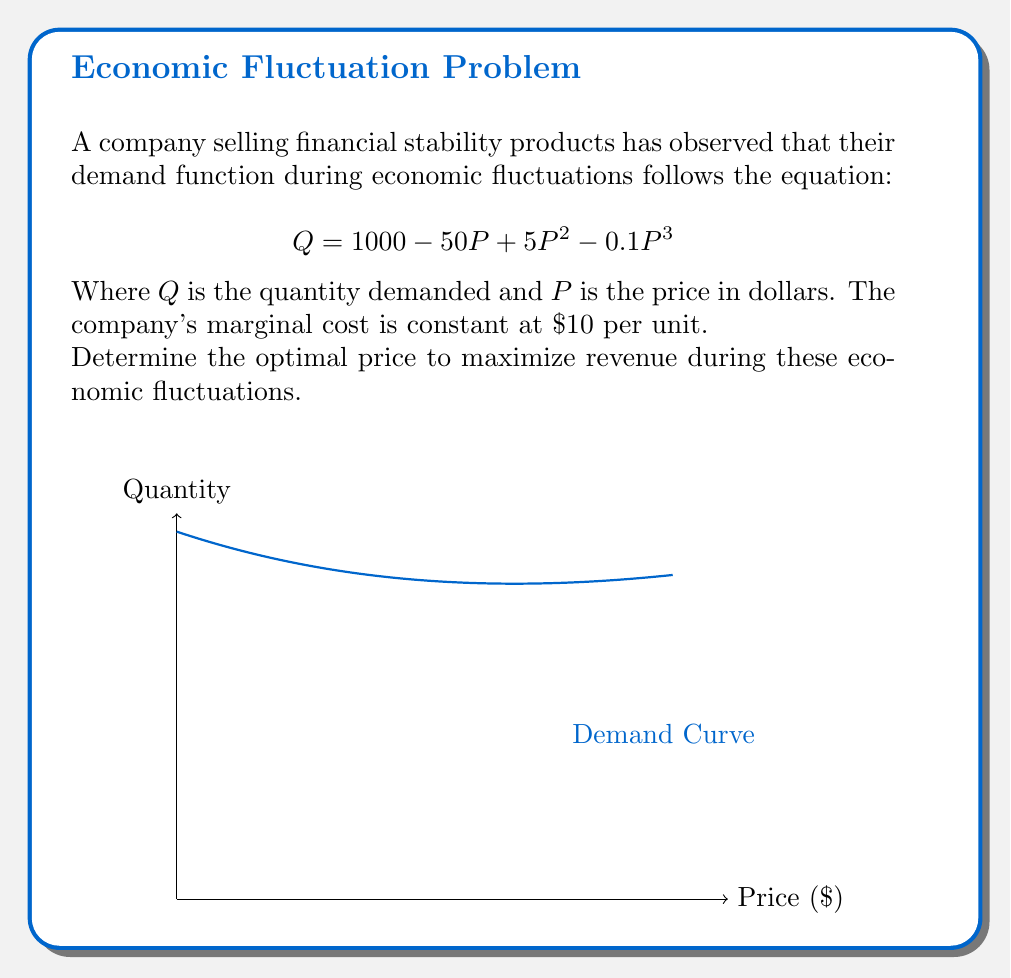Provide a solution to this math problem. To find the optimal price that maximizes revenue, we need to follow these steps:

1) Revenue function: $R = P \cdot Q = P(1000 - 50P + 5P^2 - 0.1P^3)$

2) Expand the revenue function:
   $R = 1000P - 50P^2 + 5P^3 - 0.1P^4$

3) To maximize revenue, we need to find where $\frac{dR}{dP} = 0$:

   $\frac{dR}{dP} = 1000 - 100P + 15P^2 - 0.4P^3$

4) Set this equal to zero:
   $1000 - 100P + 15P^2 - 0.4P^3 = 0$

5) This is a cubic equation. We can solve it numerically or using a graphing calculator. The solution that maximizes revenue is approximately $P = 16.67$.

6) To verify this is a maximum, we can check the second derivative is negative at this point:

   $\frac{d^2R}{dP^2} = -100 + 30P - 1.2P^2$
   
   At $P = 16.67$, $\frac{d^2R}{dP^2} \approx -100 + 30(16.67) - 1.2(16.67)^2 \approx -236.7 < 0$

Therefore, the optimal price to maximize revenue is approximately $16.67.
Answer: $16.67 